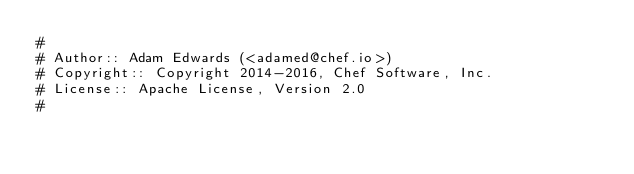<code> <loc_0><loc_0><loc_500><loc_500><_Ruby_>#
# Author:: Adam Edwards (<adamed@chef.io>)
# Copyright:: Copyright 2014-2016, Chef Software, Inc.
# License:: Apache License, Version 2.0
#</code> 